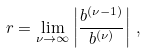<formula> <loc_0><loc_0><loc_500><loc_500>r = \lim _ { \nu \to \infty } \left | \frac { b ^ { ( \nu - 1 ) } } { b ^ { ( \nu ) } } \right | \, ,</formula> 